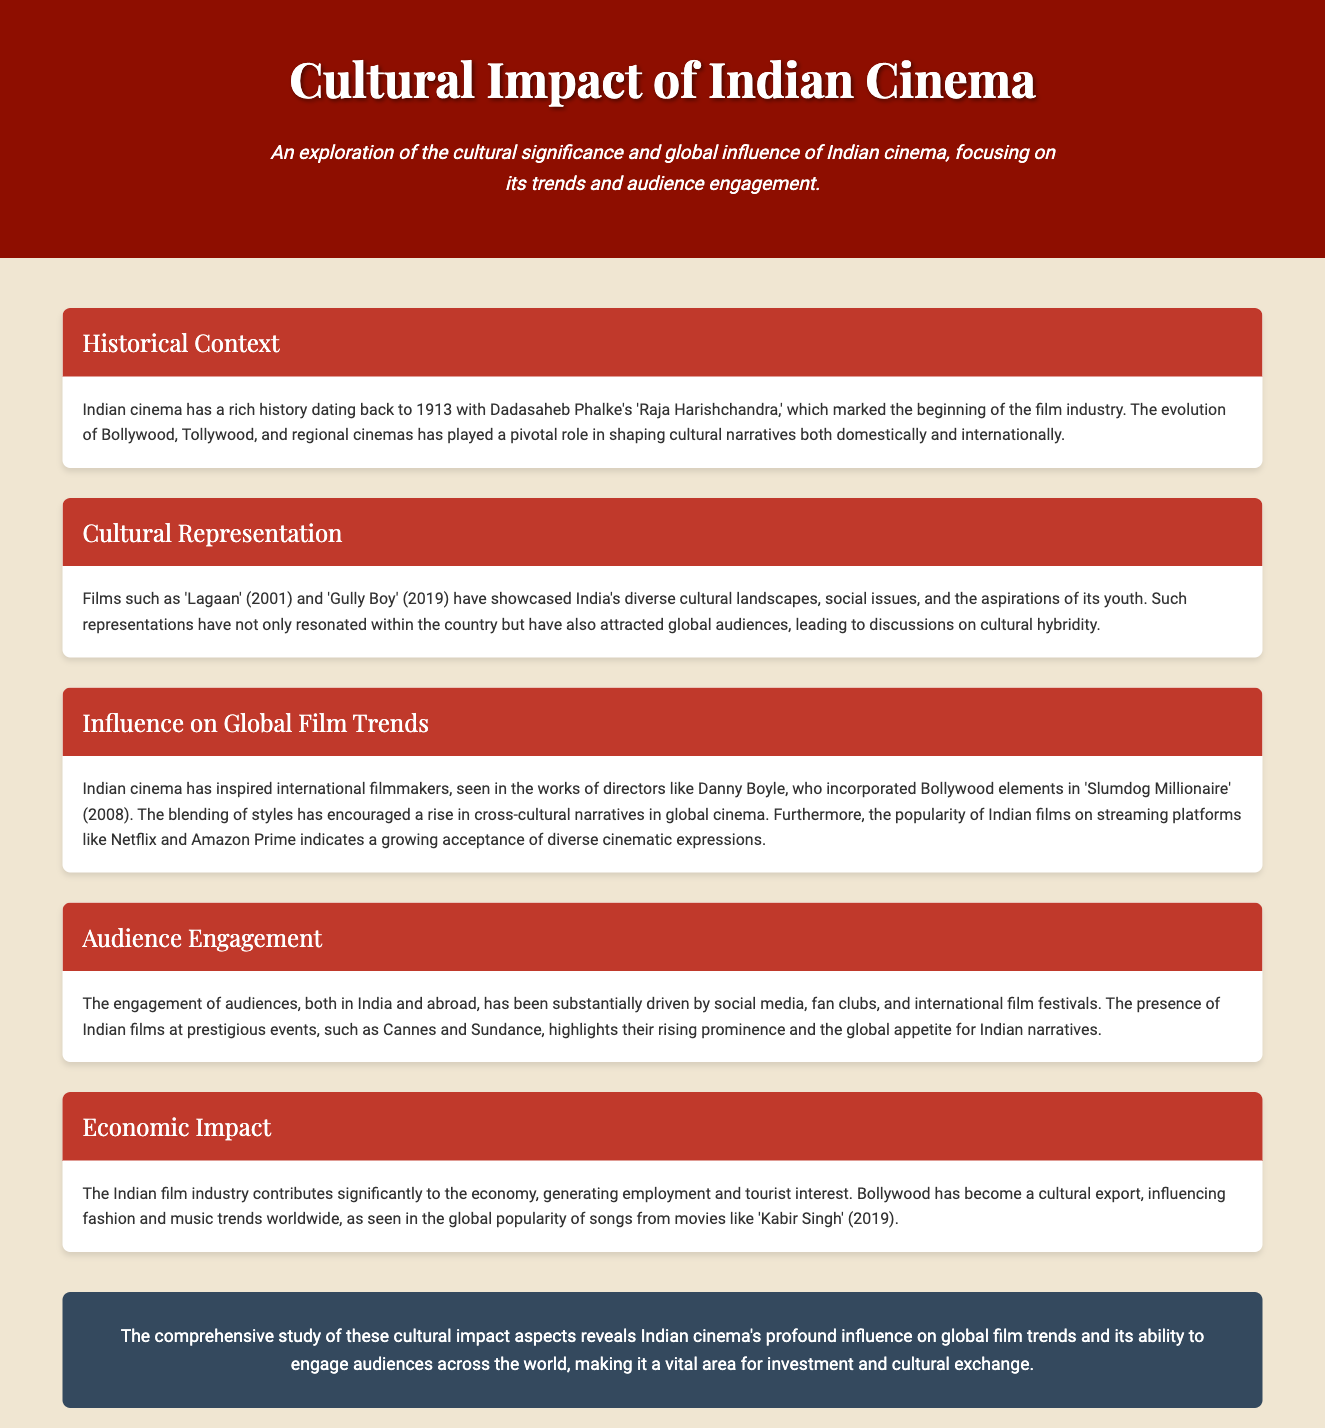what year marked the beginning of Indian cinema? The beginning of Indian cinema is marked by Dadasaheb Phalke's 'Raja Harishchandra,' which was released in 1913.
Answer: 1913 which film showcased India's diverse cultural landscapes and social issues? 'Lagaan' (2001) is highlighted for showcasing India's diverse cultural landscapes and social issues.
Answer: Lagaan who directed 'Slumdog Millionaire'? 'Slumdog Millionaire' was directed by Danny Boyle, who incorporated Bollywood elements into the film.
Answer: Danny Boyle what has driven audience engagement for Indian films? Social media, fan clubs, and international film festivals have significantly driven audience engagement.
Answer: Social media how much does the Indian film industry contribute to the economy? The Indian film industry contributes significantly by generating employment and attracting tourist interest.
Answer: Significantly which platform indicates the growing acceptance of Indian cinema? The popularity of Indian films on streaming platforms like Netflix and Amazon Prime indicates this acceptance.
Answer: Netflix and Amazon Prime what is one cultural export of Bollywood mentioned in the document? Bollywood has influenced fashion trends worldwide as a cultural export.
Answer: Fashion name a film that gained global popularity in music trends. The global popularity of songs from 'Kabir Singh' (2019) is noted in the document.
Answer: Kabir Singh what is the concluding statement about Indian cinema's influence? The study reveals Indian cinema's profound influence on global film trends and audience engagement.
Answer: Profound influence 